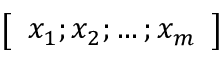<formula> <loc_0><loc_0><loc_500><loc_500>\left [ \begin{array} { l } { x _ { 1 } ; x _ { 2 } ; \dots ; x _ { m } } \end{array} \right ]</formula> 